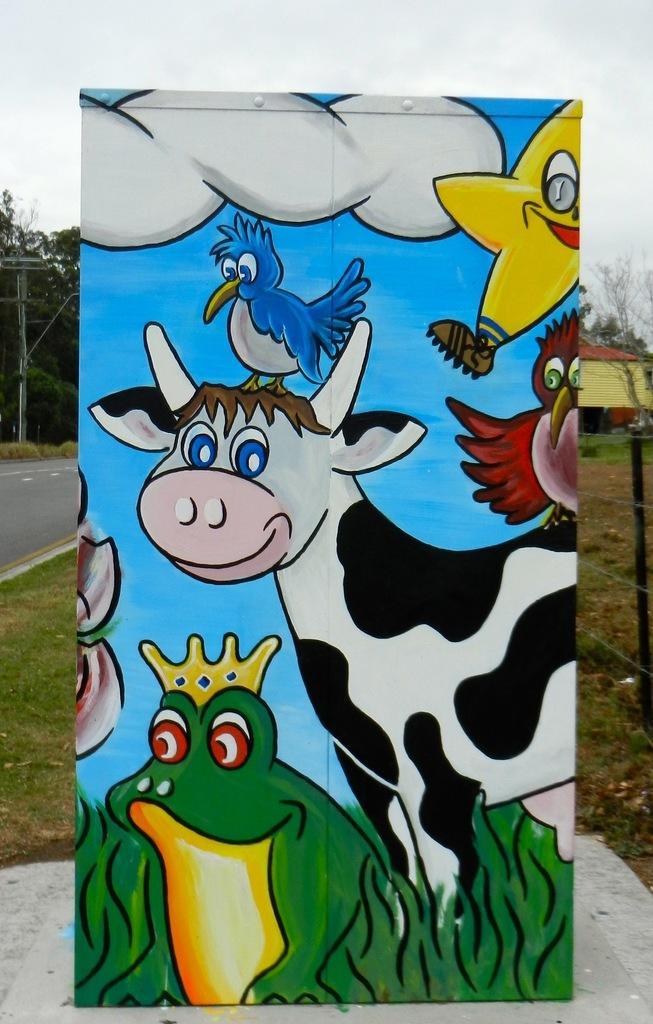Could you give a brief overview of what you see in this image? In the center of the image we can see a board with painting. In the background of the image there is road. There are trees. There is a house. There is grass. 